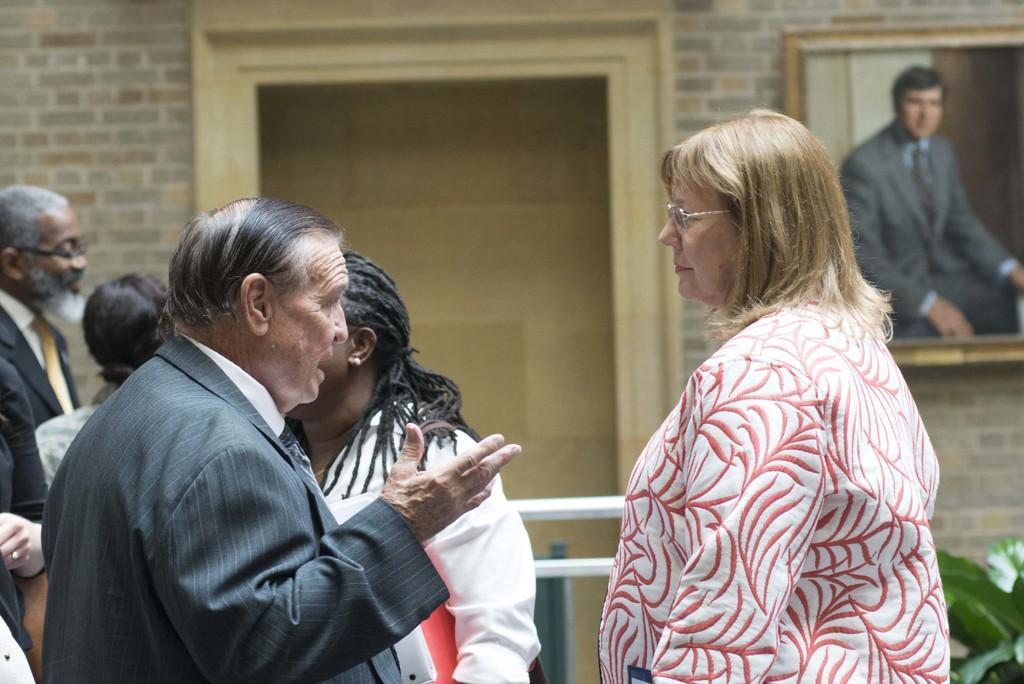Describe this image in one or two sentences. In this image we can see persons standing. In the background we can see iron rods, wall and a window. There is also a photo frame attached on the wall. 